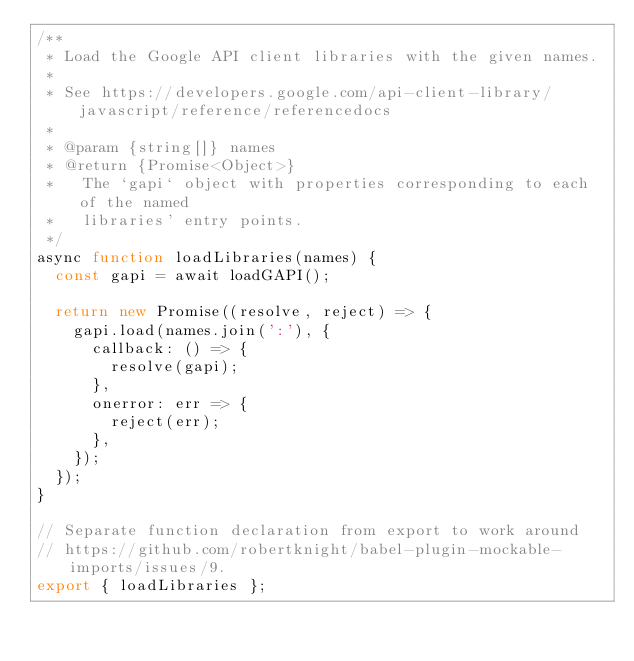<code> <loc_0><loc_0><loc_500><loc_500><_JavaScript_>/**
 * Load the Google API client libraries with the given names.
 *
 * See https://developers.google.com/api-client-library/javascript/reference/referencedocs
 *
 * @param {string[]} names
 * @return {Promise<Object>}
 *   The `gapi` object with properties corresponding to each of the named
 *   libraries' entry points.
 */
async function loadLibraries(names) {
  const gapi = await loadGAPI();

  return new Promise((resolve, reject) => {
    gapi.load(names.join(':'), {
      callback: () => {
        resolve(gapi);
      },
      onerror: err => {
        reject(err);
      },
    });
  });
}

// Separate function declaration from export to work around
// https://github.com/robertknight/babel-plugin-mockable-imports/issues/9.
export { loadLibraries };
</code> 